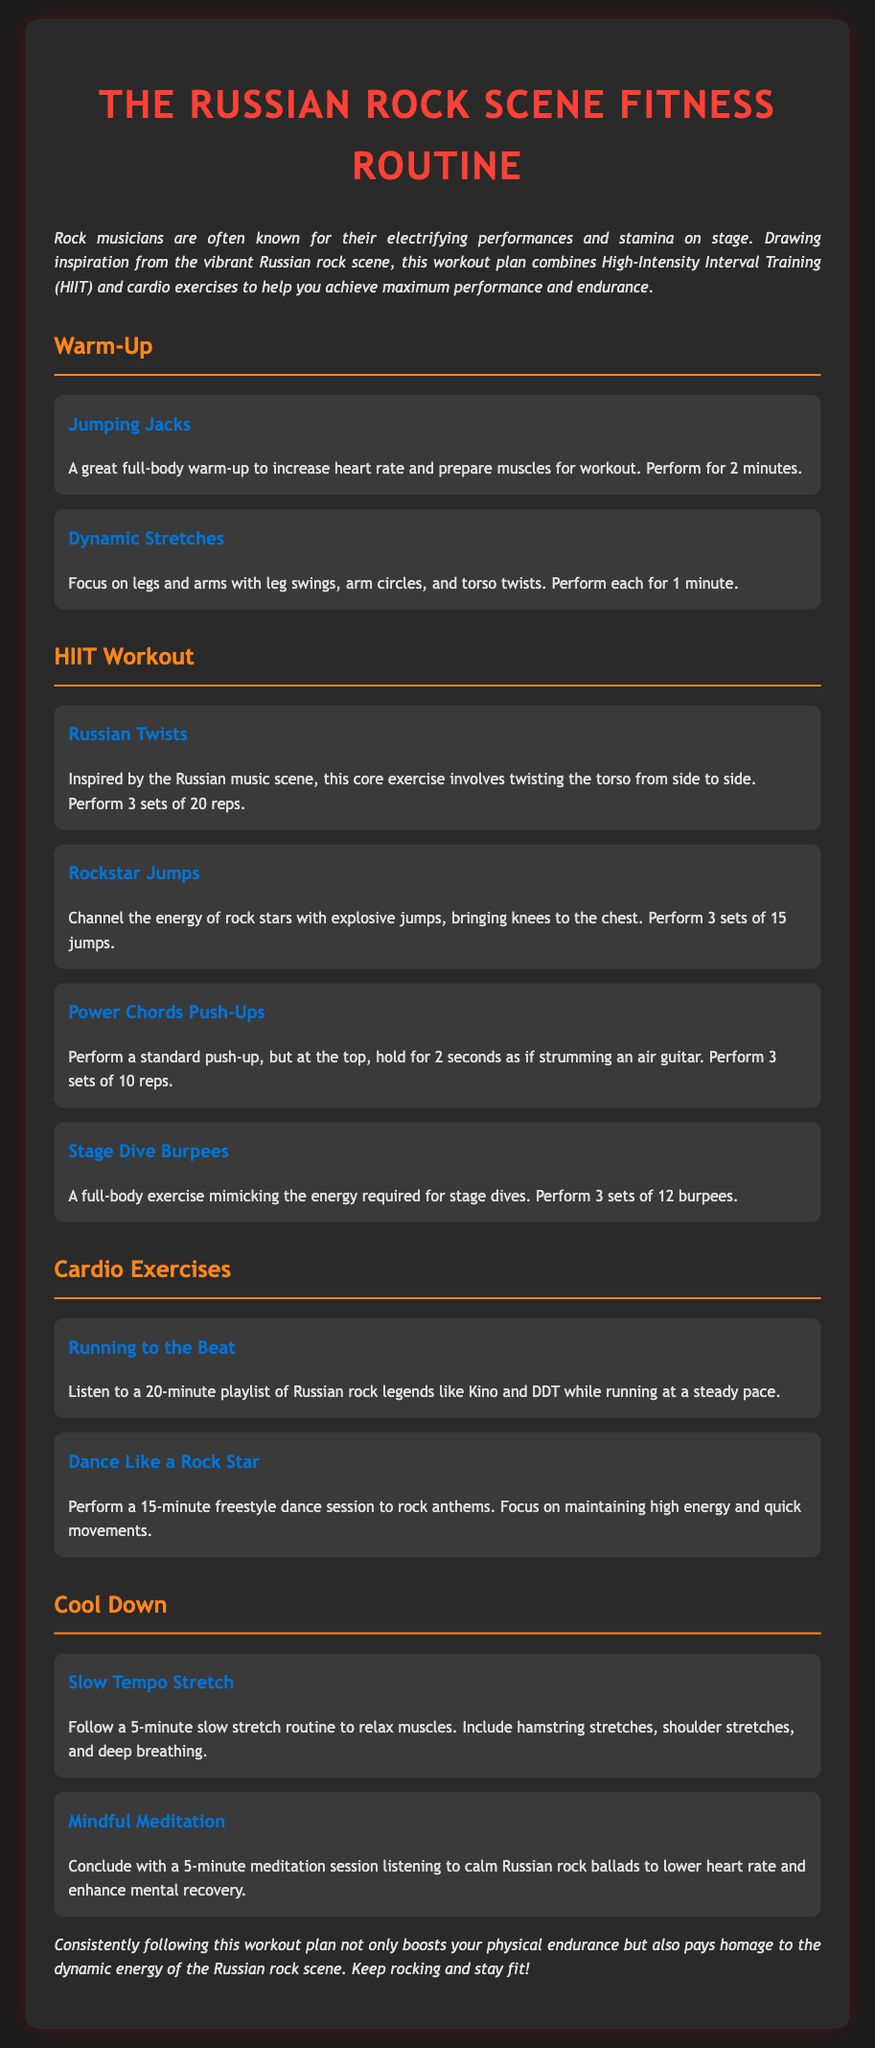What is the title of the workout plan? The title of the workout plan, as indicated at the top of the document, is "The Russian Rock Scene Fitness Routine."
Answer: The Russian Rock Scene Fitness Routine How long should you perform jumping jacks during the warm-up? The document specifies that you should perform jumping jacks for 2 minutes as part of the warm-up routine.
Answer: 2 minutes How many sets of Russian twists are recommended? According to the document, you should perform 3 sets of 20 repetitions of Russian twists.
Answer: 3 sets of 20 reps What is the duration of the running exercise? The running exercise to the beat should last for 20 minutes, as mentioned in the cardio exercises section.
Answer: 20 minutes What type of stretches are performed in the cool-down? The document describes a "Slow Tempo Stretch" routine as part of the cool-down.
Answer: Slow Tempo Stretch What is included in the cool-down meditation? The document mentions a 5-minute meditation session listening to calm Russian rock ballads.
Answer: 5-minute meditation session How many burpees are suggested for the stage dive burpees exercise? The recommended number of stage dive burpees to perform is 3 sets of 12, as per the HIIT workout section.
Answer: 3 sets of 12 What is the main inspiration behind the workout plan? The main inspiration behind the workout plan is the "vibrant Russian rock scene," as stated in the introduction.
Answer: Vibrant Russian rock scene What is the purpose of the HIIT workout in this routine? The HIIT workout aims to maximize performance and endurance, combining intensive movements as described in the introduction.
Answer: Maximize performance and endurance 